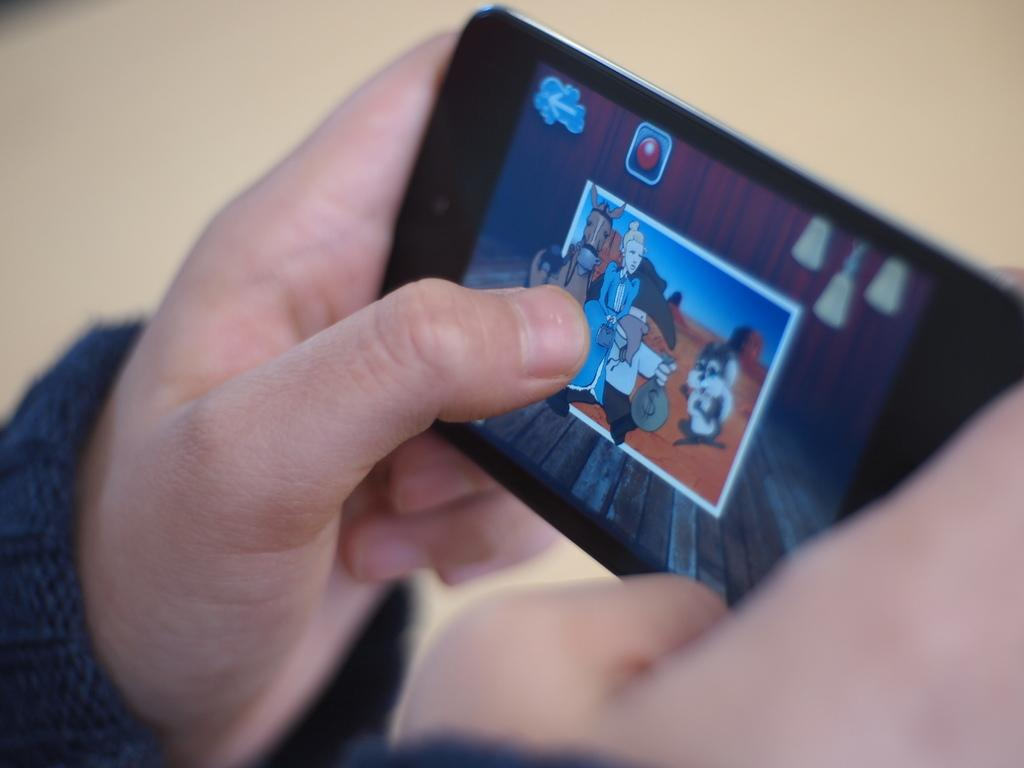What is the person in the image doing? The person is holding a mobile phone and playing a game on it. What color is the mobile phone the person is using? The mobile phone is black in color. Can you describe the activity the person is engaged in? The person is playing a game on their mobile phone. What direction is the person walking in the image? There is no indication of the person walking in the image; they are holding a mobile phone and playing a game. How much fuel is left in the person's car in the image? There is no car or mention of fuel in the image; it only shows a person playing a game on their mobile phone. 